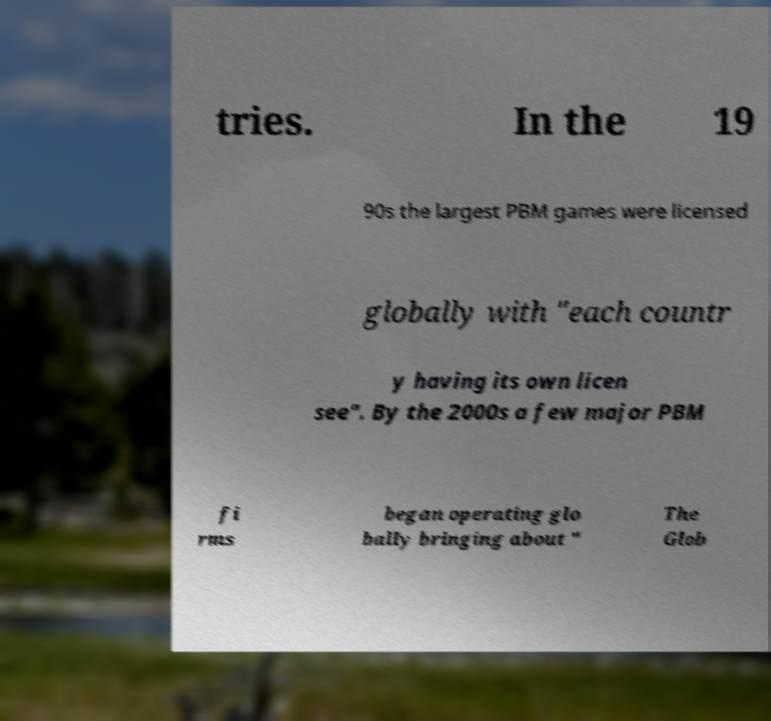For documentation purposes, I need the text within this image transcribed. Could you provide that? tries. In the 19 90s the largest PBM games were licensed globally with "each countr y having its own licen see". By the 2000s a few major PBM fi rms began operating glo bally bringing about " The Glob 